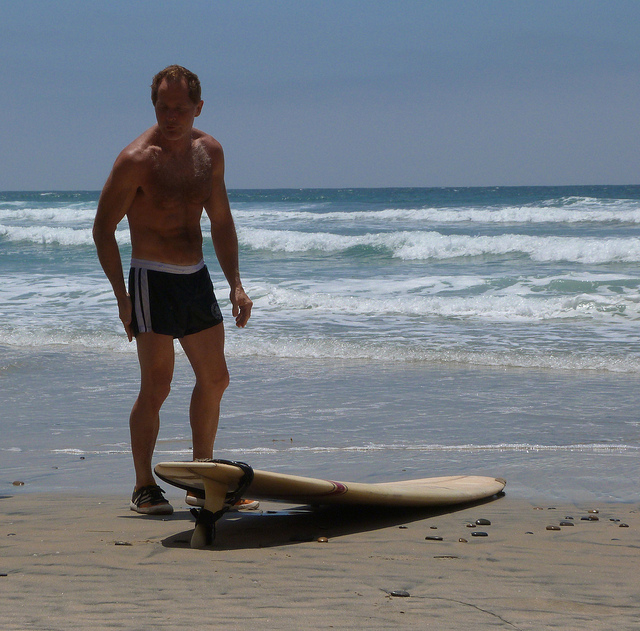Is the surfboard attached to the man in any way? Yes, there is a strap, commonly known as a leash, that connects the surfboard to the man's ankle. This leash helps keep the surfboard close to him when in the water. 